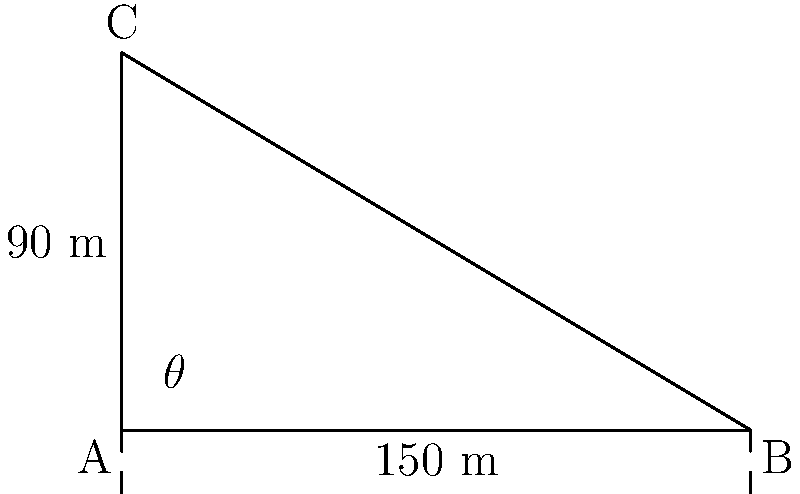As a dam engineer, you're tasked with determining the slope angle of a new dam project. The dam has a base length of 150 meters and a height of 90 meters. What is the angle $\theta$ between the dam face and the horizontal base, rounded to the nearest degree? To solve this problem, we'll use trigonometry, specifically the arctangent function. Let's approach this step-by-step:

1) In this scenario, we have a right-angled triangle where:
   - The base (adjacent side to angle $\theta$) is 150 meters
   - The height (opposite side to angle $\theta$) is 90 meters

2) We need to find the angle $\theta$. The tangent of an angle in a right-angled triangle is given by:

   $\tan(\theta) = \frac{\text{opposite}}{\text{adjacent}}$

3) Substituting our values:

   $\tan(\theta) = \frac{90}{150} = 0.6$

4) To find $\theta$, we need to take the inverse tangent (arctangent) of this value:

   $\theta = \arctan(0.6)$

5) Using a calculator or computer:

   $\theta \approx 30.9638^\circ$

6) Rounding to the nearest degree:

   $\theta \approx 31^\circ$

This angle represents the slope of the dam face with respect to the horizontal base.
Answer: $31^\circ$ 